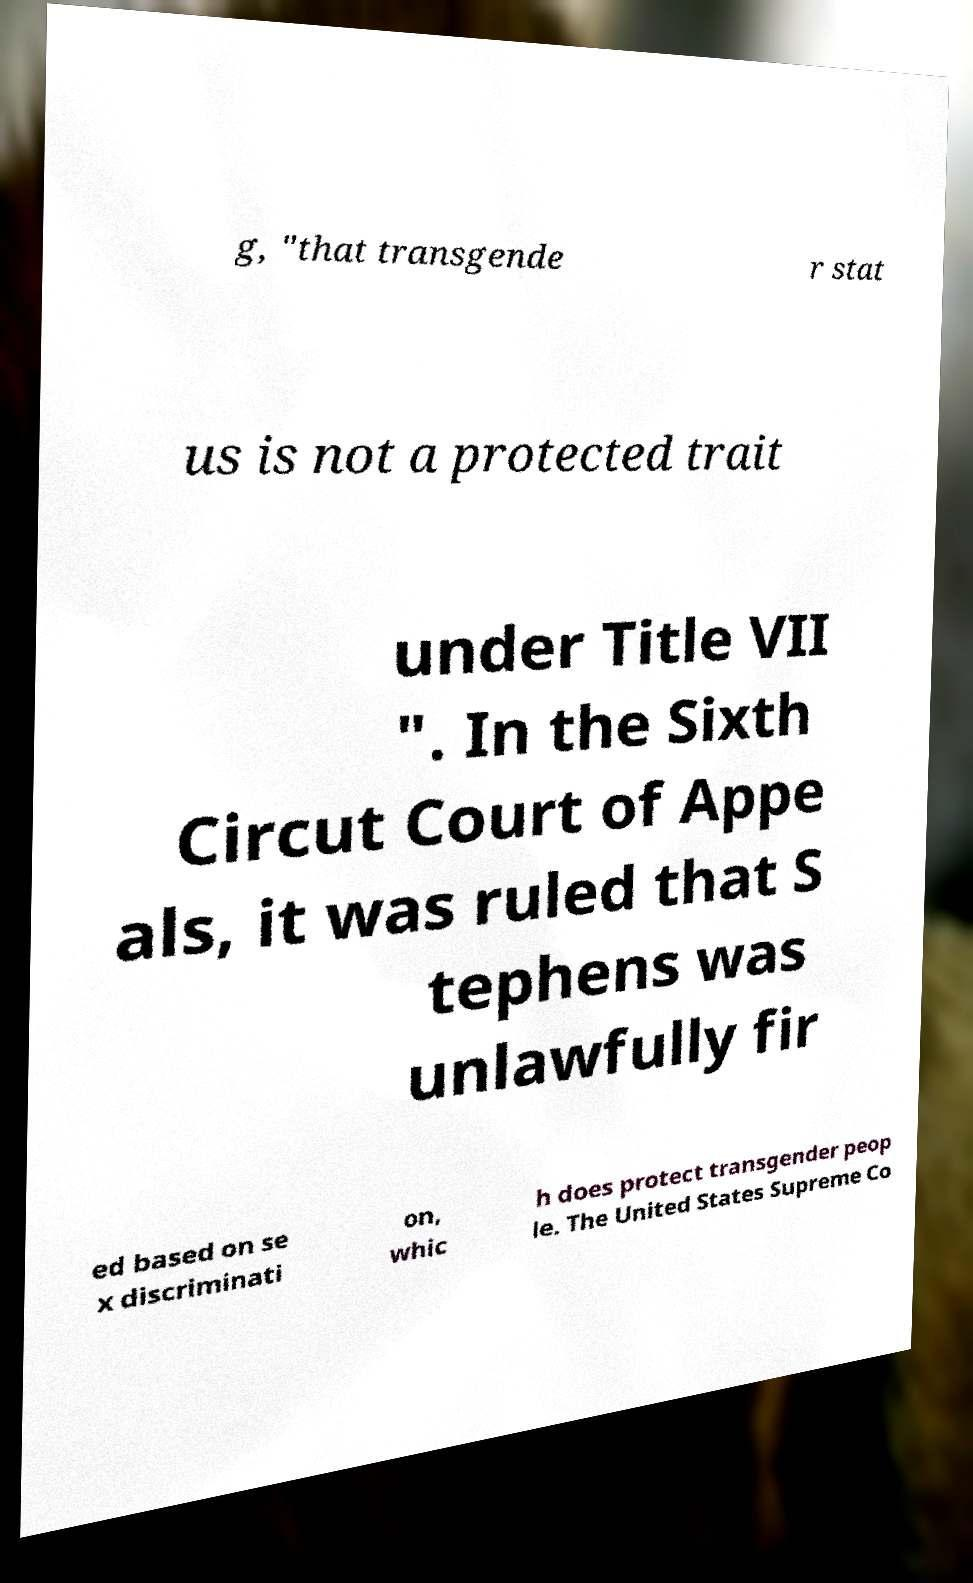For documentation purposes, I need the text within this image transcribed. Could you provide that? g, "that transgende r stat us is not a protected trait under Title VII ". In the Sixth Circut Court of Appe als, it was ruled that S tephens was unlawfully fir ed based on se x discriminati on, whic h does protect transgender peop le. The United States Supreme Co 